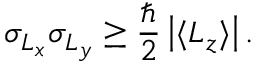<formula> <loc_0><loc_0><loc_500><loc_500>\sigma _ { L _ { x } } \sigma _ { L _ { y } } \geq { \frac { } { 2 } } \left | \langle L _ { z } \rangle \right | .</formula> 